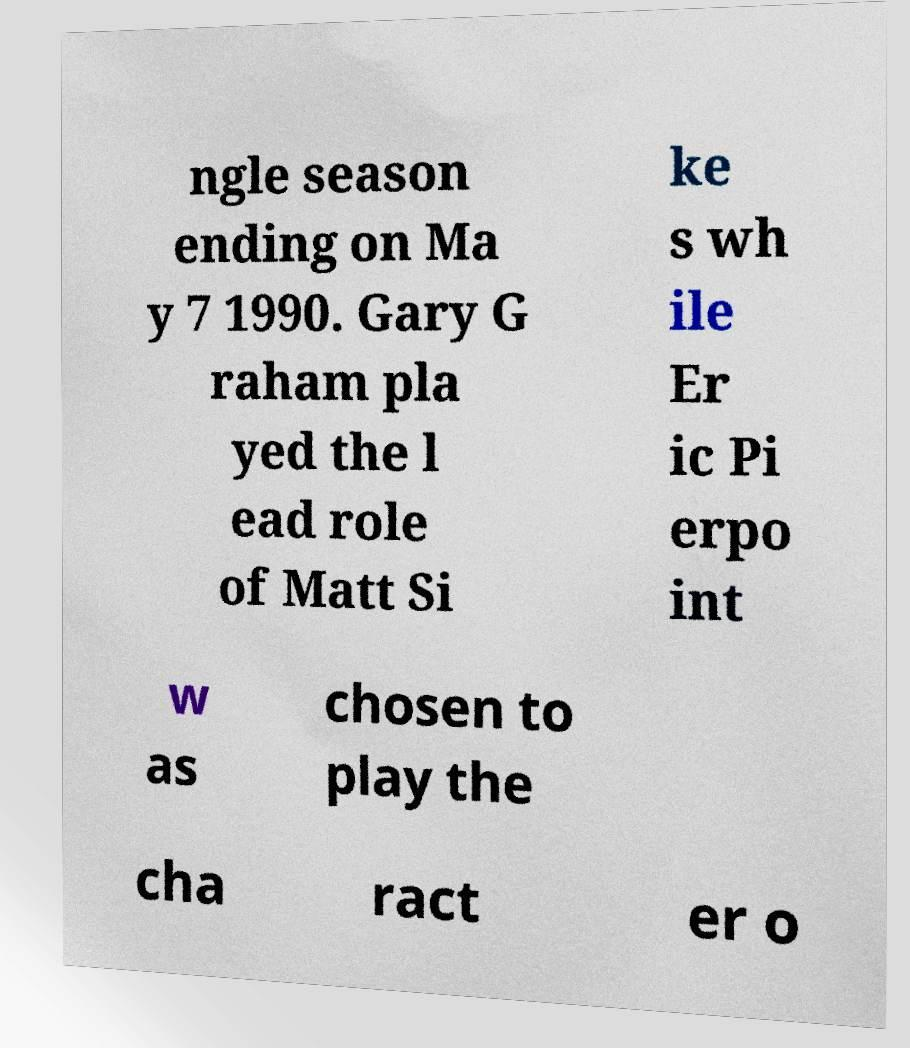There's text embedded in this image that I need extracted. Can you transcribe it verbatim? ngle season ending on Ma y 7 1990. Gary G raham pla yed the l ead role of Matt Si ke s wh ile Er ic Pi erpo int w as chosen to play the cha ract er o 